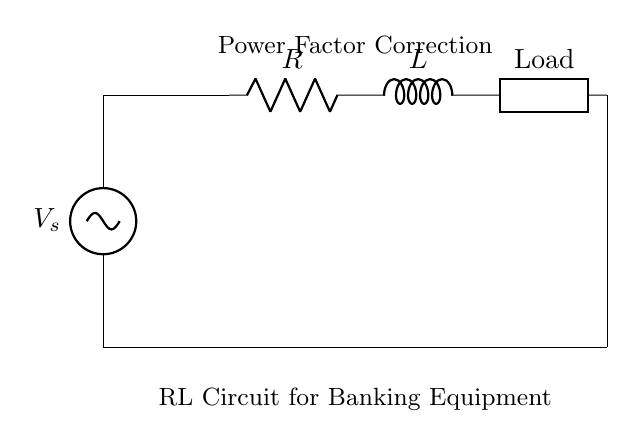What is the type of load in this circuit? The load is labeled as "Load," indicating a generic or unspecified load that the RL circuit powers.
Answer: Load What is the role of the resistor in this circuit? The resistor limits the current flowing through the circuit, dissipating energy as heat, which is essential for power factor correction.
Answer: Current limiter What is the function of the inductor in this circuit? The inductor stores energy in a magnetic field when current flows through it, which helps improve the power factor by delaying the current phase.
Answer: Energy storage What is the purpose of the "Power Factor Correction" label? This label indicates that the circuit is designed to improve the power factor, which is crucial in banking equipment to ensure efficient power usage and reduce losses.
Answer: Improve efficiency What is the connection type between the components? The components are connected in series, meaning current flows sequentially through the resistor, inductor, and load.
Answer: Series connection What could be the consequence of a low power factor in banking equipment? A low power factor can lead to higher energy costs and potential penalties from utility companies, and it may cause overheating in equipment.
Answer: Higher costs 